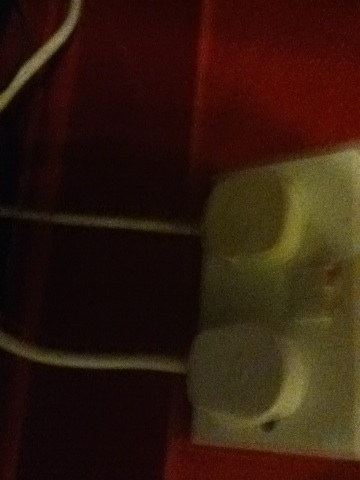What is it? The image is too blurred to make out specific details clearly; however, it seems to feature an object with a white surface, possibly an electrical outlet or switch, against a red background. 